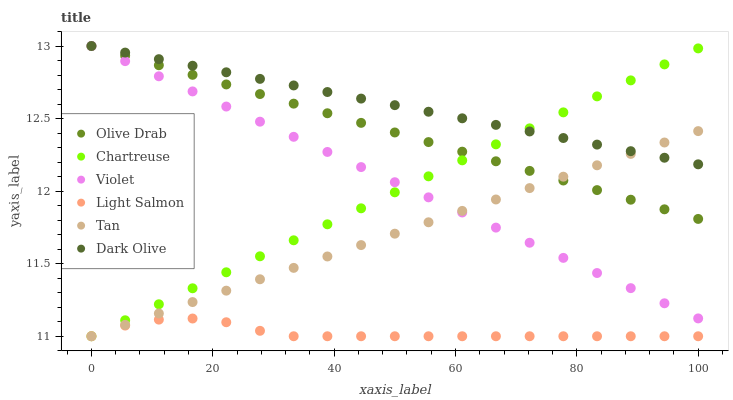Does Light Salmon have the minimum area under the curve?
Answer yes or no. Yes. Does Dark Olive have the maximum area under the curve?
Answer yes or no. Yes. Does Chartreuse have the minimum area under the curve?
Answer yes or no. No. Does Chartreuse have the maximum area under the curve?
Answer yes or no. No. Is Tan the smoothest?
Answer yes or no. Yes. Is Light Salmon the roughest?
Answer yes or no. Yes. Is Dark Olive the smoothest?
Answer yes or no. No. Is Dark Olive the roughest?
Answer yes or no. No. Does Light Salmon have the lowest value?
Answer yes or no. Yes. Does Dark Olive have the lowest value?
Answer yes or no. No. Does Olive Drab have the highest value?
Answer yes or no. Yes. Does Chartreuse have the highest value?
Answer yes or no. No. Is Light Salmon less than Olive Drab?
Answer yes or no. Yes. Is Dark Olive greater than Light Salmon?
Answer yes or no. Yes. Does Tan intersect Violet?
Answer yes or no. Yes. Is Tan less than Violet?
Answer yes or no. No. Is Tan greater than Violet?
Answer yes or no. No. Does Light Salmon intersect Olive Drab?
Answer yes or no. No. 